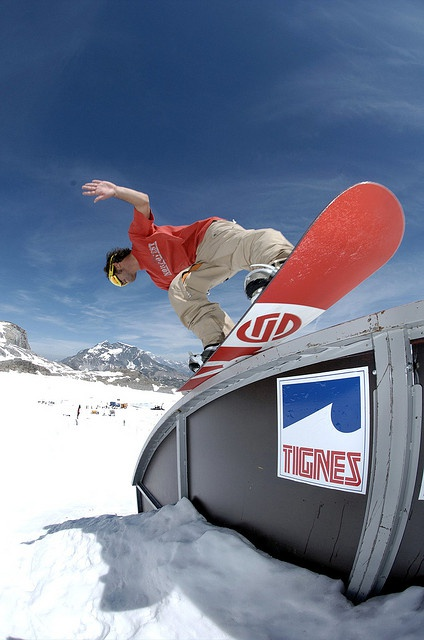Describe the objects in this image and their specific colors. I can see boat in darkblue, gray, darkgray, black, and lavender tones, snowboard in darkblue, red, brown, and lightgray tones, and people in darkblue, darkgray, brown, and gray tones in this image. 